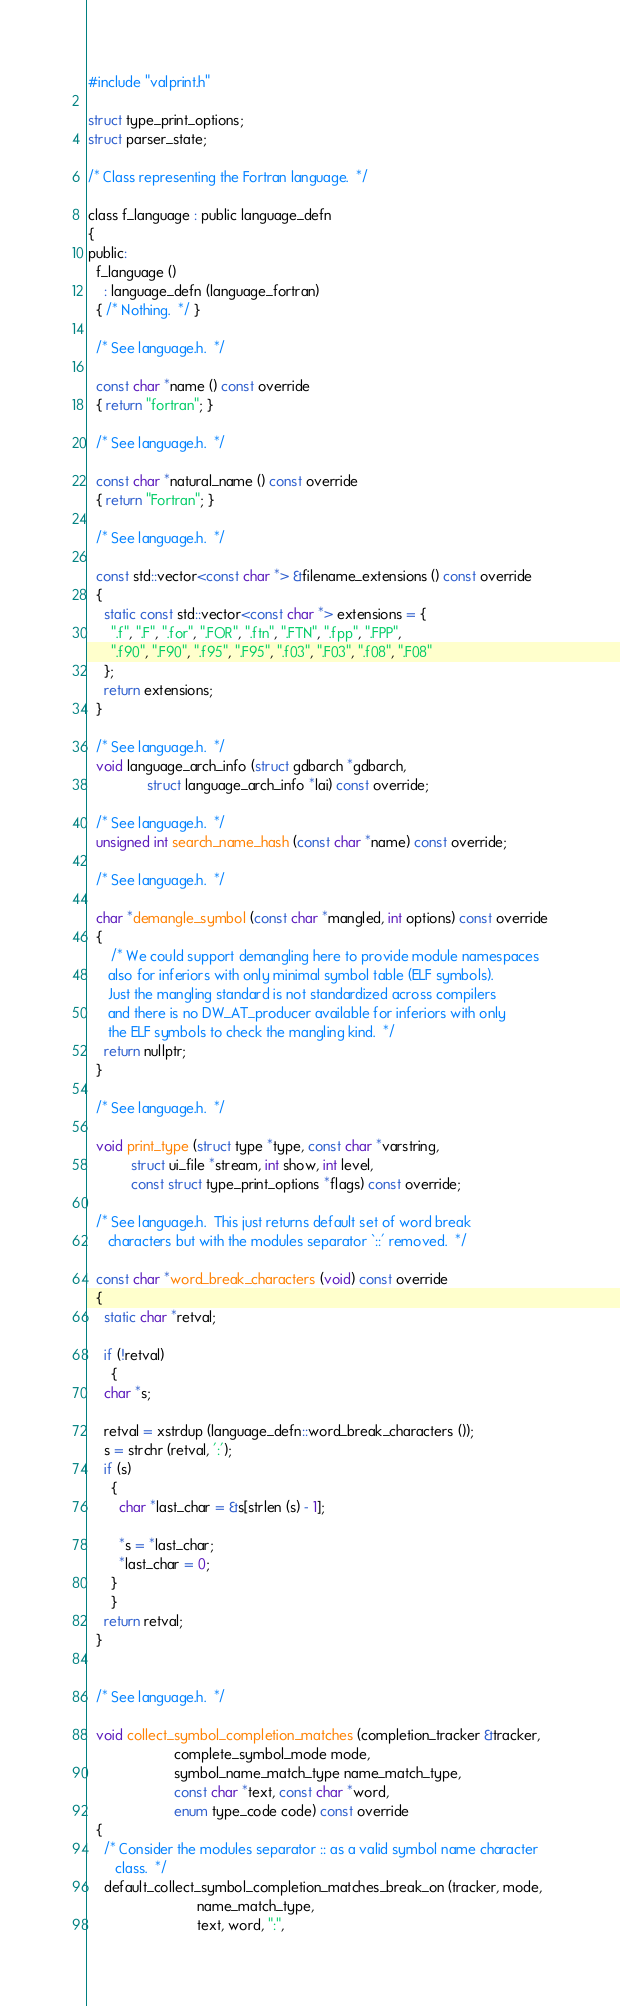Convert code to text. <code><loc_0><loc_0><loc_500><loc_500><_C_>
#include "valprint.h"

struct type_print_options;
struct parser_state;

/* Class representing the Fortran language.  */

class f_language : public language_defn
{
public:
  f_language ()
    : language_defn (language_fortran)
  { /* Nothing.  */ }

  /* See language.h.  */

  const char *name () const override
  { return "fortran"; }

  /* See language.h.  */

  const char *natural_name () const override
  { return "Fortran"; }

  /* See language.h.  */

  const std::vector<const char *> &filename_extensions () const override
  {
    static const std::vector<const char *> extensions = {
      ".f", ".F", ".for", ".FOR", ".ftn", ".FTN", ".fpp", ".FPP",
      ".f90", ".F90", ".f95", ".F95", ".f03", ".F03", ".f08", ".F08"
    };
    return extensions;
  }

  /* See language.h.  */
  void language_arch_info (struct gdbarch *gdbarch,
			   struct language_arch_info *lai) const override;

  /* See language.h.  */
  unsigned int search_name_hash (const char *name) const override;

  /* See language.h.  */

  char *demangle_symbol (const char *mangled, int options) const override
  {
      /* We could support demangling here to provide module namespaces
	 also for inferiors with only minimal symbol table (ELF symbols).
	 Just the mangling standard is not standardized across compilers
	 and there is no DW_AT_producer available for inferiors with only
	 the ELF symbols to check the mangling kind.  */
    return nullptr;
  }

  /* See language.h.  */

  void print_type (struct type *type, const char *varstring,
		   struct ui_file *stream, int show, int level,
		   const struct type_print_options *flags) const override;

  /* See language.h.  This just returns default set of word break
     characters but with the modules separator `::' removed.  */

  const char *word_break_characters (void) const override
  {
    static char *retval;

    if (!retval)
      {
	char *s;

	retval = xstrdup (language_defn::word_break_characters ());
	s = strchr (retval, ':');
	if (s)
	  {
	    char *last_char = &s[strlen (s) - 1];

	    *s = *last_char;
	    *last_char = 0;
	  }
      }
    return retval;
  }


  /* See language.h.  */

  void collect_symbol_completion_matches (completion_tracker &tracker,
					  complete_symbol_mode mode,
					  symbol_name_match_type name_match_type,
					  const char *text, const char *word,
					  enum type_code code) const override
  {
    /* Consider the modules separator :: as a valid symbol name character
       class.  */
    default_collect_symbol_completion_matches_break_on (tracker, mode,
							name_match_type,
							text, word, ":",</code> 